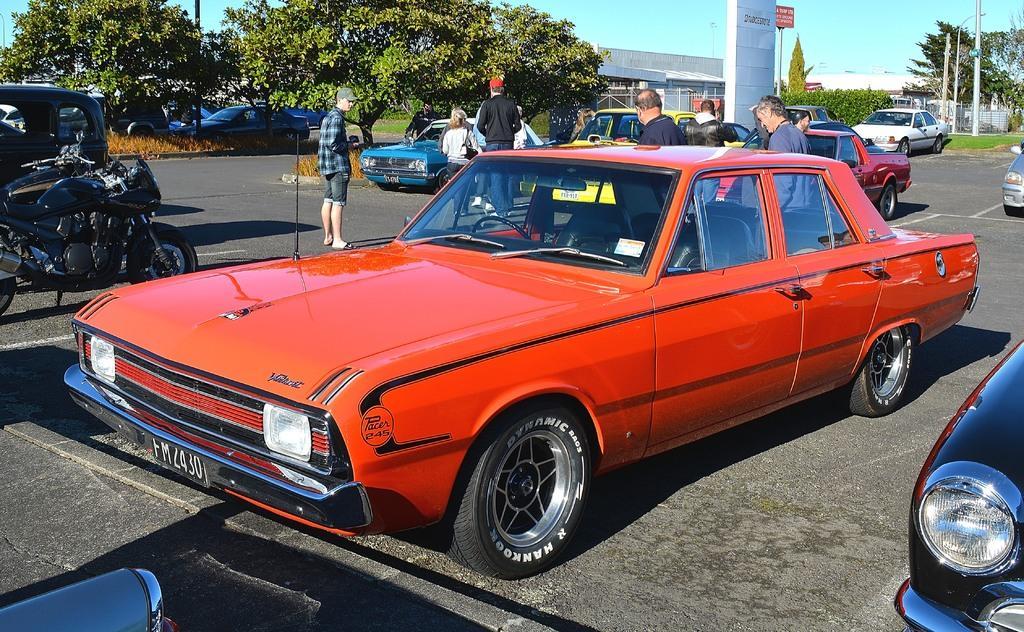Please provide a concise description of this image. In this picture there is a vehicle which is in red color and there is another car which is in black color in the right corner and there are few other vehicles in the left corner and there are few persons,vehicles,trees,buildings and poles in the background. 